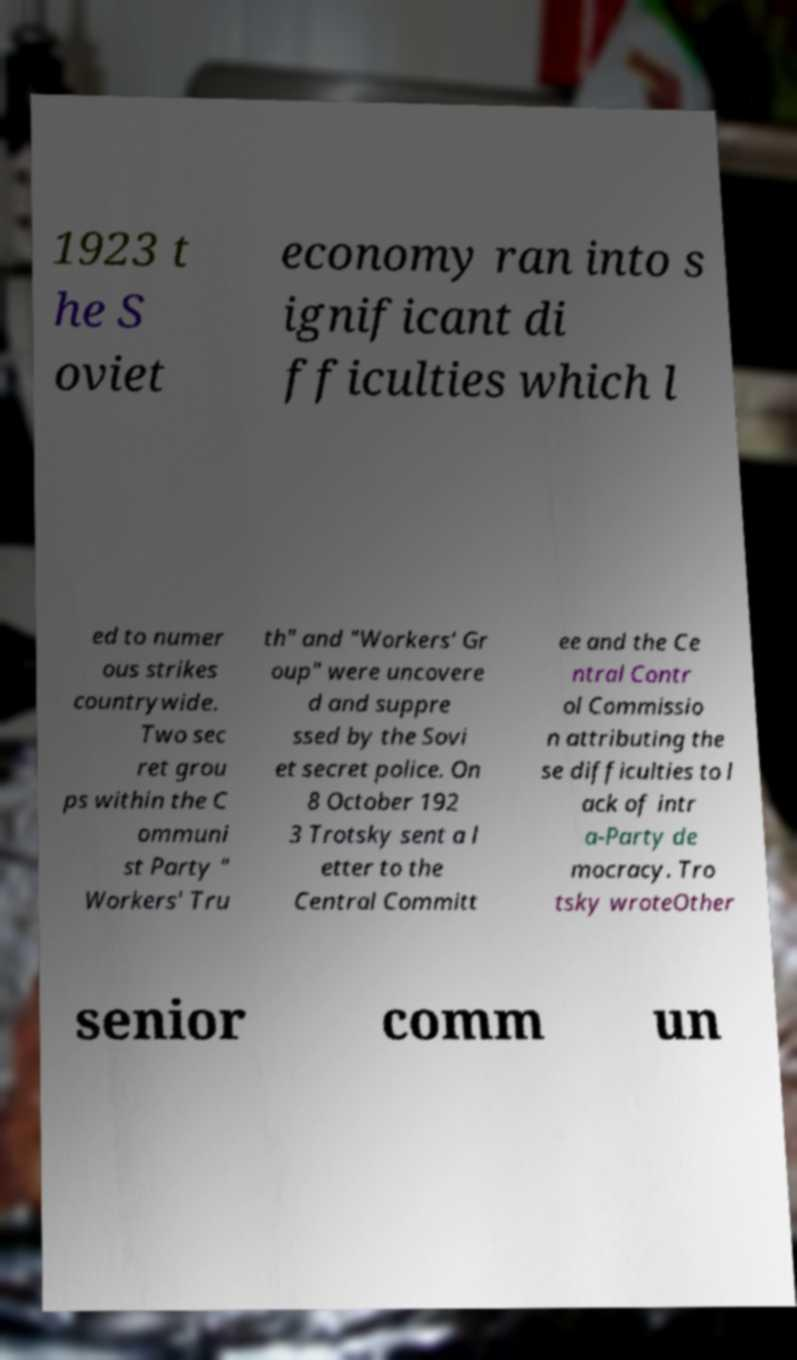I need the written content from this picture converted into text. Can you do that? 1923 t he S oviet economy ran into s ignificant di fficulties which l ed to numer ous strikes countrywide. Two sec ret grou ps within the C ommuni st Party " Workers' Tru th" and "Workers' Gr oup" were uncovere d and suppre ssed by the Sovi et secret police. On 8 October 192 3 Trotsky sent a l etter to the Central Committ ee and the Ce ntral Contr ol Commissio n attributing the se difficulties to l ack of intr a-Party de mocracy. Tro tsky wroteOther senior comm un 